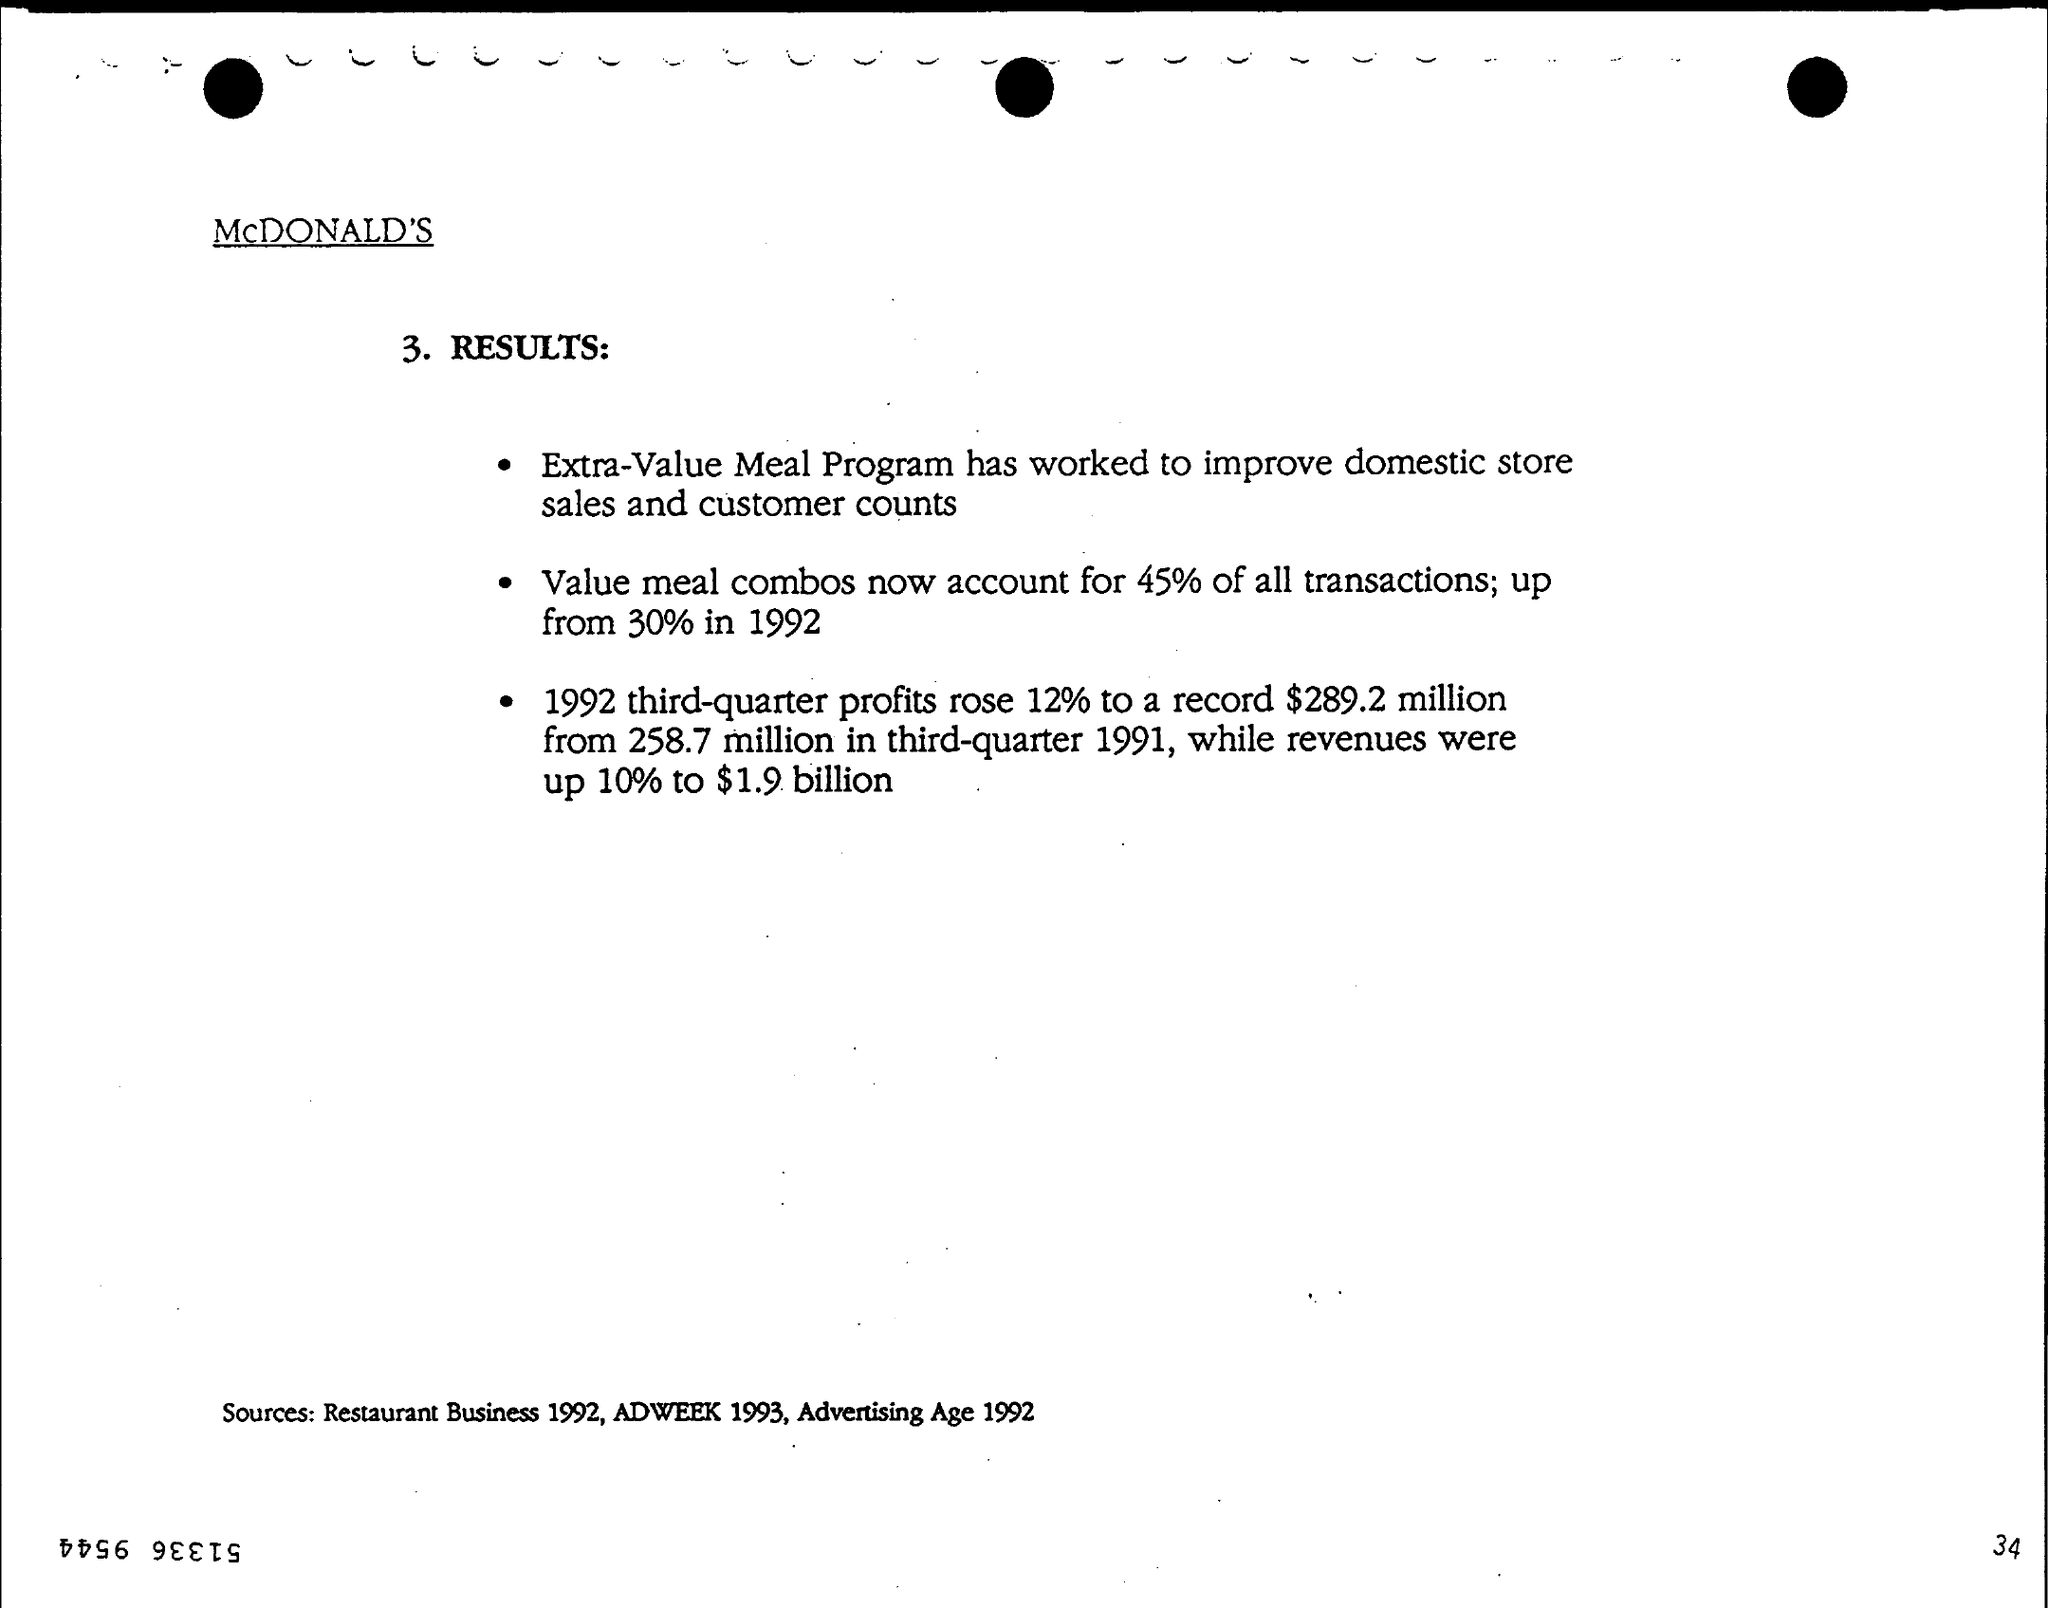Draw attention to some important aspects in this diagram. In the third quarter of 1992, profits rose by 12% compared to the previous quarter. The program that has been effective in increasing domestic store sales and customer counts is the Extra Value Meal program. In the year 1992, approximately 30% of all value meal combinations were sold. In comparison to 1992, meal combinations now account for 45%. 